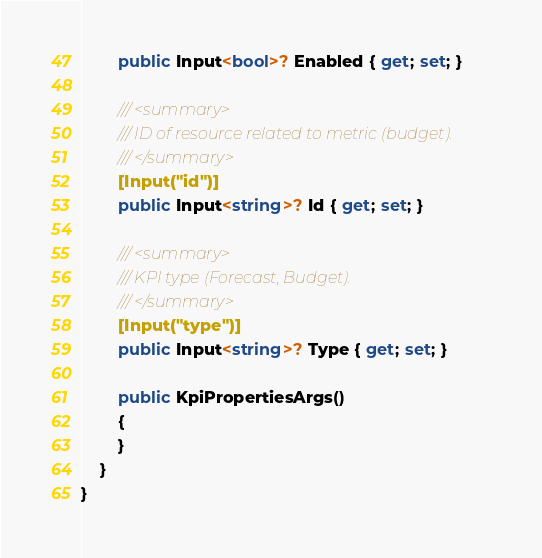<code> <loc_0><loc_0><loc_500><loc_500><_C#_>        public Input<bool>? Enabled { get; set; }

        /// <summary>
        /// ID of resource related to metric (budget).
        /// </summary>
        [Input("id")]
        public Input<string>? Id { get; set; }

        /// <summary>
        /// KPI type (Forecast, Budget).
        /// </summary>
        [Input("type")]
        public Input<string>? Type { get; set; }

        public KpiPropertiesArgs()
        {
        }
    }
}
</code> 